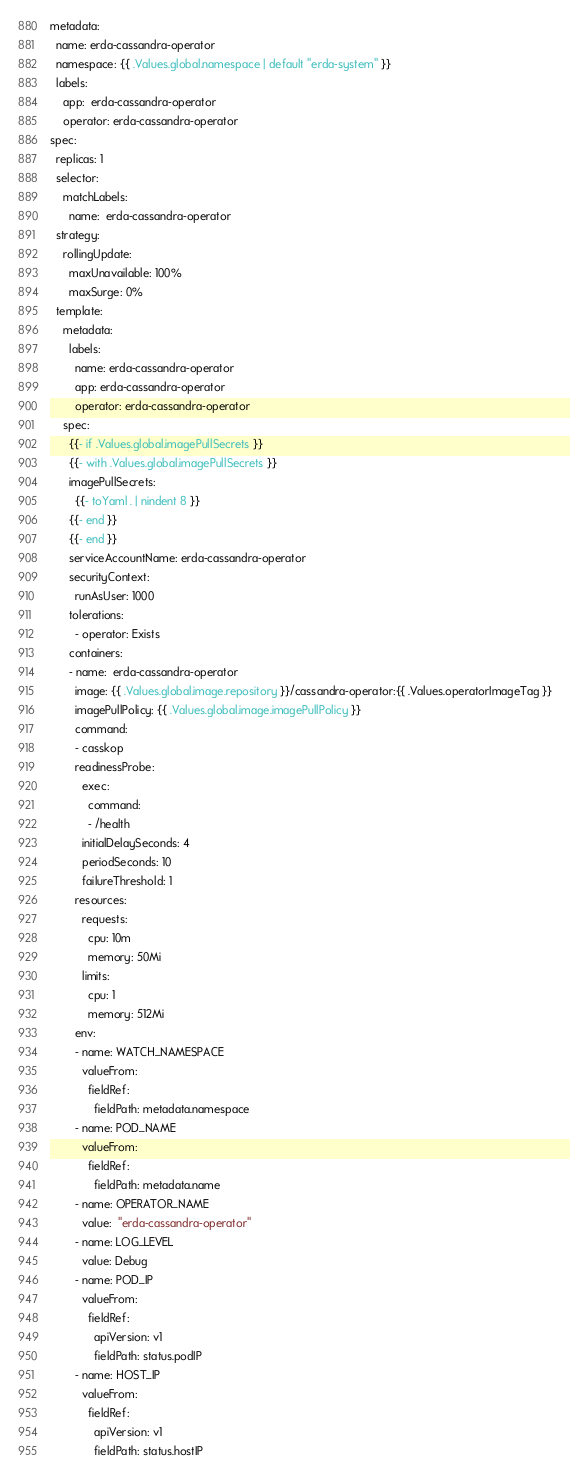Convert code to text. <code><loc_0><loc_0><loc_500><loc_500><_YAML_>metadata:
  name: erda-cassandra-operator
  namespace: {{ .Values.global.namespace | default "erda-system" }}
  labels:
    app:  erda-cassandra-operator
    operator: erda-cassandra-operator
spec:
  replicas: 1
  selector:
    matchLabels:
      name:  erda-cassandra-operator
  strategy:
    rollingUpdate:
      maxUnavailable: 100%
      maxSurge: 0%
  template:
    metadata:
      labels:
        name: erda-cassandra-operator
        app: erda-cassandra-operator
        operator: erda-cassandra-operator
    spec:
      {{- if .Values.global.imagePullSecrets }}
      {{- with .Values.global.imagePullSecrets }}
      imagePullSecrets:
        {{- toYaml . | nindent 8 }}
      {{- end }}
      {{- end }}
      serviceAccountName: erda-cassandra-operator
      securityContext:
        runAsUser: 1000
      tolerations:
        - operator: Exists
      containers:
      - name:  erda-cassandra-operator
        image: {{ .Values.global.image.repository }}/cassandra-operator:{{ .Values.operatorImageTag }}
        imagePullPolicy: {{ .Values.global.image.imagePullPolicy }}
        command:
        - casskop
        readinessProbe:
          exec:
            command:
            - /health
          initialDelaySeconds: 4
          periodSeconds: 10
          failureThreshold: 1
        resources:
          requests:
            cpu: 10m
            memory: 50Mi
          limits:
            cpu: 1
            memory: 512Mi
        env:
        - name: WATCH_NAMESPACE
          valueFrom:
            fieldRef:
              fieldPath: metadata.namespace
        - name: POD_NAME
          valueFrom:
            fieldRef:
              fieldPath: metadata.name
        - name: OPERATOR_NAME
          value:  "erda-cassandra-operator"
        - name: LOG_LEVEL
          value: Debug
        - name: POD_IP
          valueFrom:
            fieldRef:
              apiVersion: v1
              fieldPath: status.podIP
        - name: HOST_IP
          valueFrom:
            fieldRef:
              apiVersion: v1
              fieldPath: status.hostIP
</code> 